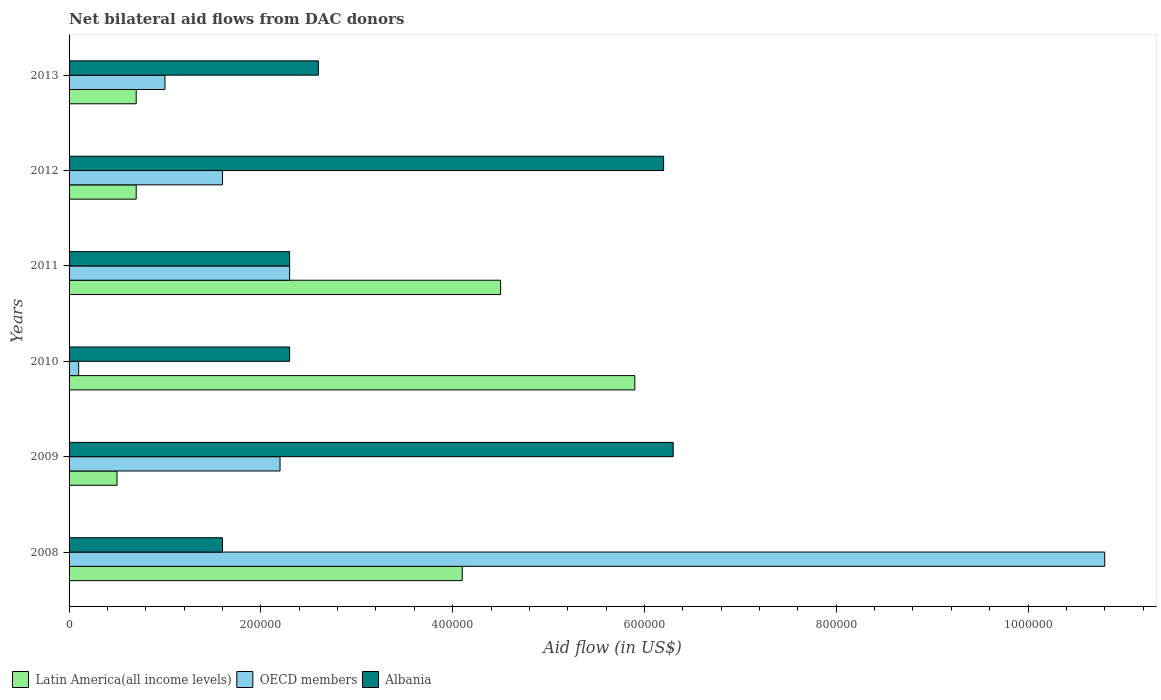How many groups of bars are there?
Ensure brevity in your answer.  6. How many bars are there on the 3rd tick from the top?
Keep it short and to the point. 3. How many bars are there on the 6th tick from the bottom?
Give a very brief answer. 3. What is the label of the 6th group of bars from the top?
Offer a very short reply. 2008. In how many cases, is the number of bars for a given year not equal to the number of legend labels?
Your response must be concise. 0. What is the net bilateral aid flow in Albania in 2009?
Offer a terse response. 6.30e+05. Across all years, what is the maximum net bilateral aid flow in OECD members?
Offer a very short reply. 1.08e+06. Across all years, what is the minimum net bilateral aid flow in Albania?
Make the answer very short. 1.60e+05. In which year was the net bilateral aid flow in Albania minimum?
Provide a succinct answer. 2008. What is the total net bilateral aid flow in Latin America(all income levels) in the graph?
Make the answer very short. 1.64e+06. What is the difference between the net bilateral aid flow in Latin America(all income levels) in 2008 and that in 2012?
Give a very brief answer. 3.40e+05. What is the difference between the net bilateral aid flow in Latin America(all income levels) in 2008 and the net bilateral aid flow in OECD members in 2012?
Your answer should be compact. 2.50e+05. What is the average net bilateral aid flow in Albania per year?
Ensure brevity in your answer.  3.55e+05. In the year 2012, what is the difference between the net bilateral aid flow in Albania and net bilateral aid flow in Latin America(all income levels)?
Make the answer very short. 5.50e+05. What is the ratio of the net bilateral aid flow in Albania in 2008 to that in 2010?
Provide a short and direct response. 0.7. Is the difference between the net bilateral aid flow in Albania in 2009 and 2010 greater than the difference between the net bilateral aid flow in Latin America(all income levels) in 2009 and 2010?
Your answer should be compact. Yes. What is the difference between the highest and the lowest net bilateral aid flow in Albania?
Your answer should be very brief. 4.70e+05. Is the sum of the net bilateral aid flow in Latin America(all income levels) in 2011 and 2013 greater than the maximum net bilateral aid flow in OECD members across all years?
Your answer should be compact. No. What does the 2nd bar from the top in 2013 represents?
Your answer should be compact. OECD members. What does the 2nd bar from the bottom in 2011 represents?
Your answer should be compact. OECD members. How many bars are there?
Offer a terse response. 18. Are all the bars in the graph horizontal?
Give a very brief answer. Yes. How many years are there in the graph?
Offer a very short reply. 6. Are the values on the major ticks of X-axis written in scientific E-notation?
Offer a terse response. No. Where does the legend appear in the graph?
Offer a very short reply. Bottom left. What is the title of the graph?
Provide a succinct answer. Net bilateral aid flows from DAC donors. What is the label or title of the X-axis?
Provide a succinct answer. Aid flow (in US$). What is the Aid flow (in US$) of Latin America(all income levels) in 2008?
Keep it short and to the point. 4.10e+05. What is the Aid flow (in US$) in OECD members in 2008?
Provide a short and direct response. 1.08e+06. What is the Aid flow (in US$) of Albania in 2008?
Your answer should be compact. 1.60e+05. What is the Aid flow (in US$) in Latin America(all income levels) in 2009?
Provide a succinct answer. 5.00e+04. What is the Aid flow (in US$) in Albania in 2009?
Your answer should be very brief. 6.30e+05. What is the Aid flow (in US$) in Latin America(all income levels) in 2010?
Offer a very short reply. 5.90e+05. What is the Aid flow (in US$) in OECD members in 2010?
Offer a terse response. 10000. What is the Aid flow (in US$) of Albania in 2010?
Provide a succinct answer. 2.30e+05. What is the Aid flow (in US$) of Latin America(all income levels) in 2011?
Provide a short and direct response. 4.50e+05. What is the Aid flow (in US$) in Albania in 2011?
Keep it short and to the point. 2.30e+05. What is the Aid flow (in US$) in Latin America(all income levels) in 2012?
Offer a terse response. 7.00e+04. What is the Aid flow (in US$) in OECD members in 2012?
Your response must be concise. 1.60e+05. What is the Aid flow (in US$) of Albania in 2012?
Provide a succinct answer. 6.20e+05. What is the Aid flow (in US$) in Albania in 2013?
Offer a terse response. 2.60e+05. Across all years, what is the maximum Aid flow (in US$) of Latin America(all income levels)?
Your response must be concise. 5.90e+05. Across all years, what is the maximum Aid flow (in US$) in OECD members?
Provide a short and direct response. 1.08e+06. Across all years, what is the maximum Aid flow (in US$) of Albania?
Give a very brief answer. 6.30e+05. What is the total Aid flow (in US$) in Latin America(all income levels) in the graph?
Give a very brief answer. 1.64e+06. What is the total Aid flow (in US$) of OECD members in the graph?
Give a very brief answer. 1.80e+06. What is the total Aid flow (in US$) of Albania in the graph?
Give a very brief answer. 2.13e+06. What is the difference between the Aid flow (in US$) of OECD members in 2008 and that in 2009?
Keep it short and to the point. 8.60e+05. What is the difference between the Aid flow (in US$) in Albania in 2008 and that in 2009?
Offer a terse response. -4.70e+05. What is the difference between the Aid flow (in US$) of OECD members in 2008 and that in 2010?
Keep it short and to the point. 1.07e+06. What is the difference between the Aid flow (in US$) of OECD members in 2008 and that in 2011?
Your answer should be very brief. 8.50e+05. What is the difference between the Aid flow (in US$) of OECD members in 2008 and that in 2012?
Make the answer very short. 9.20e+05. What is the difference between the Aid flow (in US$) in Albania in 2008 and that in 2012?
Give a very brief answer. -4.60e+05. What is the difference between the Aid flow (in US$) of OECD members in 2008 and that in 2013?
Your answer should be compact. 9.80e+05. What is the difference between the Aid flow (in US$) of Latin America(all income levels) in 2009 and that in 2010?
Ensure brevity in your answer.  -5.40e+05. What is the difference between the Aid flow (in US$) in OECD members in 2009 and that in 2010?
Provide a succinct answer. 2.10e+05. What is the difference between the Aid flow (in US$) in Albania in 2009 and that in 2010?
Give a very brief answer. 4.00e+05. What is the difference between the Aid flow (in US$) in Latin America(all income levels) in 2009 and that in 2011?
Keep it short and to the point. -4.00e+05. What is the difference between the Aid flow (in US$) of OECD members in 2009 and that in 2011?
Offer a terse response. -10000. What is the difference between the Aid flow (in US$) of Albania in 2009 and that in 2012?
Keep it short and to the point. 10000. What is the difference between the Aid flow (in US$) in Albania in 2009 and that in 2013?
Ensure brevity in your answer.  3.70e+05. What is the difference between the Aid flow (in US$) in Latin America(all income levels) in 2010 and that in 2012?
Your answer should be very brief. 5.20e+05. What is the difference between the Aid flow (in US$) of Albania in 2010 and that in 2012?
Your answer should be compact. -3.90e+05. What is the difference between the Aid flow (in US$) of Latin America(all income levels) in 2010 and that in 2013?
Provide a short and direct response. 5.20e+05. What is the difference between the Aid flow (in US$) of Albania in 2011 and that in 2012?
Offer a terse response. -3.90e+05. What is the difference between the Aid flow (in US$) in Latin America(all income levels) in 2011 and that in 2013?
Your response must be concise. 3.80e+05. What is the difference between the Aid flow (in US$) of Albania in 2011 and that in 2013?
Ensure brevity in your answer.  -3.00e+04. What is the difference between the Aid flow (in US$) in Latin America(all income levels) in 2012 and that in 2013?
Offer a terse response. 0. What is the difference between the Aid flow (in US$) of Latin America(all income levels) in 2008 and the Aid flow (in US$) of OECD members in 2009?
Offer a very short reply. 1.90e+05. What is the difference between the Aid flow (in US$) of Latin America(all income levels) in 2008 and the Aid flow (in US$) of Albania in 2009?
Give a very brief answer. -2.20e+05. What is the difference between the Aid flow (in US$) of OECD members in 2008 and the Aid flow (in US$) of Albania in 2010?
Offer a very short reply. 8.50e+05. What is the difference between the Aid flow (in US$) of Latin America(all income levels) in 2008 and the Aid flow (in US$) of OECD members in 2011?
Make the answer very short. 1.80e+05. What is the difference between the Aid flow (in US$) of OECD members in 2008 and the Aid flow (in US$) of Albania in 2011?
Offer a very short reply. 8.50e+05. What is the difference between the Aid flow (in US$) of OECD members in 2008 and the Aid flow (in US$) of Albania in 2013?
Offer a very short reply. 8.20e+05. What is the difference between the Aid flow (in US$) of Latin America(all income levels) in 2009 and the Aid flow (in US$) of Albania in 2010?
Offer a terse response. -1.80e+05. What is the difference between the Aid flow (in US$) of Latin America(all income levels) in 2009 and the Aid flow (in US$) of OECD members in 2011?
Offer a very short reply. -1.80e+05. What is the difference between the Aid flow (in US$) of Latin America(all income levels) in 2009 and the Aid flow (in US$) of Albania in 2011?
Offer a terse response. -1.80e+05. What is the difference between the Aid flow (in US$) in Latin America(all income levels) in 2009 and the Aid flow (in US$) in OECD members in 2012?
Offer a terse response. -1.10e+05. What is the difference between the Aid flow (in US$) of Latin America(all income levels) in 2009 and the Aid flow (in US$) of Albania in 2012?
Your answer should be compact. -5.70e+05. What is the difference between the Aid flow (in US$) in OECD members in 2009 and the Aid flow (in US$) in Albania in 2012?
Make the answer very short. -4.00e+05. What is the difference between the Aid flow (in US$) of Latin America(all income levels) in 2009 and the Aid flow (in US$) of OECD members in 2013?
Provide a short and direct response. -5.00e+04. What is the difference between the Aid flow (in US$) in Latin America(all income levels) in 2009 and the Aid flow (in US$) in Albania in 2013?
Offer a terse response. -2.10e+05. What is the difference between the Aid flow (in US$) in OECD members in 2009 and the Aid flow (in US$) in Albania in 2013?
Your response must be concise. -4.00e+04. What is the difference between the Aid flow (in US$) of Latin America(all income levels) in 2010 and the Aid flow (in US$) of OECD members in 2011?
Your answer should be compact. 3.60e+05. What is the difference between the Aid flow (in US$) in Latin America(all income levels) in 2010 and the Aid flow (in US$) in Albania in 2011?
Keep it short and to the point. 3.60e+05. What is the difference between the Aid flow (in US$) of OECD members in 2010 and the Aid flow (in US$) of Albania in 2011?
Your answer should be compact. -2.20e+05. What is the difference between the Aid flow (in US$) in Latin America(all income levels) in 2010 and the Aid flow (in US$) in OECD members in 2012?
Keep it short and to the point. 4.30e+05. What is the difference between the Aid flow (in US$) of OECD members in 2010 and the Aid flow (in US$) of Albania in 2012?
Your response must be concise. -6.10e+05. What is the difference between the Aid flow (in US$) of Latin America(all income levels) in 2010 and the Aid flow (in US$) of OECD members in 2013?
Your answer should be compact. 4.90e+05. What is the difference between the Aid flow (in US$) of Latin America(all income levels) in 2010 and the Aid flow (in US$) of Albania in 2013?
Keep it short and to the point. 3.30e+05. What is the difference between the Aid flow (in US$) in OECD members in 2011 and the Aid flow (in US$) in Albania in 2012?
Your answer should be compact. -3.90e+05. What is the difference between the Aid flow (in US$) in Latin America(all income levels) in 2011 and the Aid flow (in US$) in OECD members in 2013?
Your response must be concise. 3.50e+05. What is the difference between the Aid flow (in US$) of Latin America(all income levels) in 2011 and the Aid flow (in US$) of Albania in 2013?
Keep it short and to the point. 1.90e+05. What is the difference between the Aid flow (in US$) of OECD members in 2011 and the Aid flow (in US$) of Albania in 2013?
Your answer should be compact. -3.00e+04. What is the difference between the Aid flow (in US$) in Latin America(all income levels) in 2012 and the Aid flow (in US$) in OECD members in 2013?
Offer a terse response. -3.00e+04. What is the difference between the Aid flow (in US$) of Latin America(all income levels) in 2012 and the Aid flow (in US$) of Albania in 2013?
Your answer should be very brief. -1.90e+05. What is the average Aid flow (in US$) of Latin America(all income levels) per year?
Your answer should be very brief. 2.73e+05. What is the average Aid flow (in US$) of Albania per year?
Keep it short and to the point. 3.55e+05. In the year 2008, what is the difference between the Aid flow (in US$) in Latin America(all income levels) and Aid flow (in US$) in OECD members?
Offer a terse response. -6.70e+05. In the year 2008, what is the difference between the Aid flow (in US$) in OECD members and Aid flow (in US$) in Albania?
Ensure brevity in your answer.  9.20e+05. In the year 2009, what is the difference between the Aid flow (in US$) in Latin America(all income levels) and Aid flow (in US$) in OECD members?
Give a very brief answer. -1.70e+05. In the year 2009, what is the difference between the Aid flow (in US$) in Latin America(all income levels) and Aid flow (in US$) in Albania?
Offer a terse response. -5.80e+05. In the year 2009, what is the difference between the Aid flow (in US$) in OECD members and Aid flow (in US$) in Albania?
Keep it short and to the point. -4.10e+05. In the year 2010, what is the difference between the Aid flow (in US$) of Latin America(all income levels) and Aid flow (in US$) of OECD members?
Your answer should be very brief. 5.80e+05. In the year 2010, what is the difference between the Aid flow (in US$) of Latin America(all income levels) and Aid flow (in US$) of Albania?
Give a very brief answer. 3.60e+05. In the year 2010, what is the difference between the Aid flow (in US$) in OECD members and Aid flow (in US$) in Albania?
Your answer should be very brief. -2.20e+05. In the year 2011, what is the difference between the Aid flow (in US$) of Latin America(all income levels) and Aid flow (in US$) of OECD members?
Offer a very short reply. 2.20e+05. In the year 2011, what is the difference between the Aid flow (in US$) of OECD members and Aid flow (in US$) of Albania?
Provide a short and direct response. 0. In the year 2012, what is the difference between the Aid flow (in US$) in Latin America(all income levels) and Aid flow (in US$) in Albania?
Give a very brief answer. -5.50e+05. In the year 2012, what is the difference between the Aid flow (in US$) in OECD members and Aid flow (in US$) in Albania?
Keep it short and to the point. -4.60e+05. In the year 2013, what is the difference between the Aid flow (in US$) of Latin America(all income levels) and Aid flow (in US$) of Albania?
Ensure brevity in your answer.  -1.90e+05. In the year 2013, what is the difference between the Aid flow (in US$) in OECD members and Aid flow (in US$) in Albania?
Give a very brief answer. -1.60e+05. What is the ratio of the Aid flow (in US$) in OECD members in 2008 to that in 2009?
Your answer should be compact. 4.91. What is the ratio of the Aid flow (in US$) of Albania in 2008 to that in 2009?
Keep it short and to the point. 0.25. What is the ratio of the Aid flow (in US$) in Latin America(all income levels) in 2008 to that in 2010?
Make the answer very short. 0.69. What is the ratio of the Aid flow (in US$) in OECD members in 2008 to that in 2010?
Keep it short and to the point. 108. What is the ratio of the Aid flow (in US$) of Albania in 2008 to that in 2010?
Ensure brevity in your answer.  0.7. What is the ratio of the Aid flow (in US$) in Latin America(all income levels) in 2008 to that in 2011?
Give a very brief answer. 0.91. What is the ratio of the Aid flow (in US$) in OECD members in 2008 to that in 2011?
Your answer should be very brief. 4.7. What is the ratio of the Aid flow (in US$) of Albania in 2008 to that in 2011?
Your response must be concise. 0.7. What is the ratio of the Aid flow (in US$) of Latin America(all income levels) in 2008 to that in 2012?
Your response must be concise. 5.86. What is the ratio of the Aid flow (in US$) in OECD members in 2008 to that in 2012?
Ensure brevity in your answer.  6.75. What is the ratio of the Aid flow (in US$) of Albania in 2008 to that in 2012?
Offer a very short reply. 0.26. What is the ratio of the Aid flow (in US$) of Latin America(all income levels) in 2008 to that in 2013?
Give a very brief answer. 5.86. What is the ratio of the Aid flow (in US$) in OECD members in 2008 to that in 2013?
Your response must be concise. 10.8. What is the ratio of the Aid flow (in US$) in Albania in 2008 to that in 2013?
Give a very brief answer. 0.62. What is the ratio of the Aid flow (in US$) of Latin America(all income levels) in 2009 to that in 2010?
Your answer should be compact. 0.08. What is the ratio of the Aid flow (in US$) of OECD members in 2009 to that in 2010?
Your response must be concise. 22. What is the ratio of the Aid flow (in US$) of Albania in 2009 to that in 2010?
Your answer should be very brief. 2.74. What is the ratio of the Aid flow (in US$) in OECD members in 2009 to that in 2011?
Your response must be concise. 0.96. What is the ratio of the Aid flow (in US$) of Albania in 2009 to that in 2011?
Give a very brief answer. 2.74. What is the ratio of the Aid flow (in US$) of Latin America(all income levels) in 2009 to that in 2012?
Ensure brevity in your answer.  0.71. What is the ratio of the Aid flow (in US$) in OECD members in 2009 to that in 2012?
Keep it short and to the point. 1.38. What is the ratio of the Aid flow (in US$) of Albania in 2009 to that in 2012?
Make the answer very short. 1.02. What is the ratio of the Aid flow (in US$) of Latin America(all income levels) in 2009 to that in 2013?
Give a very brief answer. 0.71. What is the ratio of the Aid flow (in US$) in Albania in 2009 to that in 2013?
Give a very brief answer. 2.42. What is the ratio of the Aid flow (in US$) of Latin America(all income levels) in 2010 to that in 2011?
Offer a terse response. 1.31. What is the ratio of the Aid flow (in US$) in OECD members in 2010 to that in 2011?
Ensure brevity in your answer.  0.04. What is the ratio of the Aid flow (in US$) in Latin America(all income levels) in 2010 to that in 2012?
Ensure brevity in your answer.  8.43. What is the ratio of the Aid flow (in US$) of OECD members in 2010 to that in 2012?
Ensure brevity in your answer.  0.06. What is the ratio of the Aid flow (in US$) of Albania in 2010 to that in 2012?
Your answer should be compact. 0.37. What is the ratio of the Aid flow (in US$) of Latin America(all income levels) in 2010 to that in 2013?
Your response must be concise. 8.43. What is the ratio of the Aid flow (in US$) in Albania in 2010 to that in 2013?
Make the answer very short. 0.88. What is the ratio of the Aid flow (in US$) of Latin America(all income levels) in 2011 to that in 2012?
Offer a terse response. 6.43. What is the ratio of the Aid flow (in US$) in OECD members in 2011 to that in 2012?
Give a very brief answer. 1.44. What is the ratio of the Aid flow (in US$) in Albania in 2011 to that in 2012?
Offer a terse response. 0.37. What is the ratio of the Aid flow (in US$) of Latin America(all income levels) in 2011 to that in 2013?
Provide a succinct answer. 6.43. What is the ratio of the Aid flow (in US$) in OECD members in 2011 to that in 2013?
Offer a very short reply. 2.3. What is the ratio of the Aid flow (in US$) in Albania in 2011 to that in 2013?
Keep it short and to the point. 0.88. What is the ratio of the Aid flow (in US$) of Latin America(all income levels) in 2012 to that in 2013?
Give a very brief answer. 1. What is the ratio of the Aid flow (in US$) of Albania in 2012 to that in 2013?
Keep it short and to the point. 2.38. What is the difference between the highest and the second highest Aid flow (in US$) of Latin America(all income levels)?
Offer a terse response. 1.40e+05. What is the difference between the highest and the second highest Aid flow (in US$) in OECD members?
Offer a terse response. 8.50e+05. What is the difference between the highest and the lowest Aid flow (in US$) of Latin America(all income levels)?
Make the answer very short. 5.40e+05. What is the difference between the highest and the lowest Aid flow (in US$) in OECD members?
Offer a very short reply. 1.07e+06. What is the difference between the highest and the lowest Aid flow (in US$) in Albania?
Make the answer very short. 4.70e+05. 